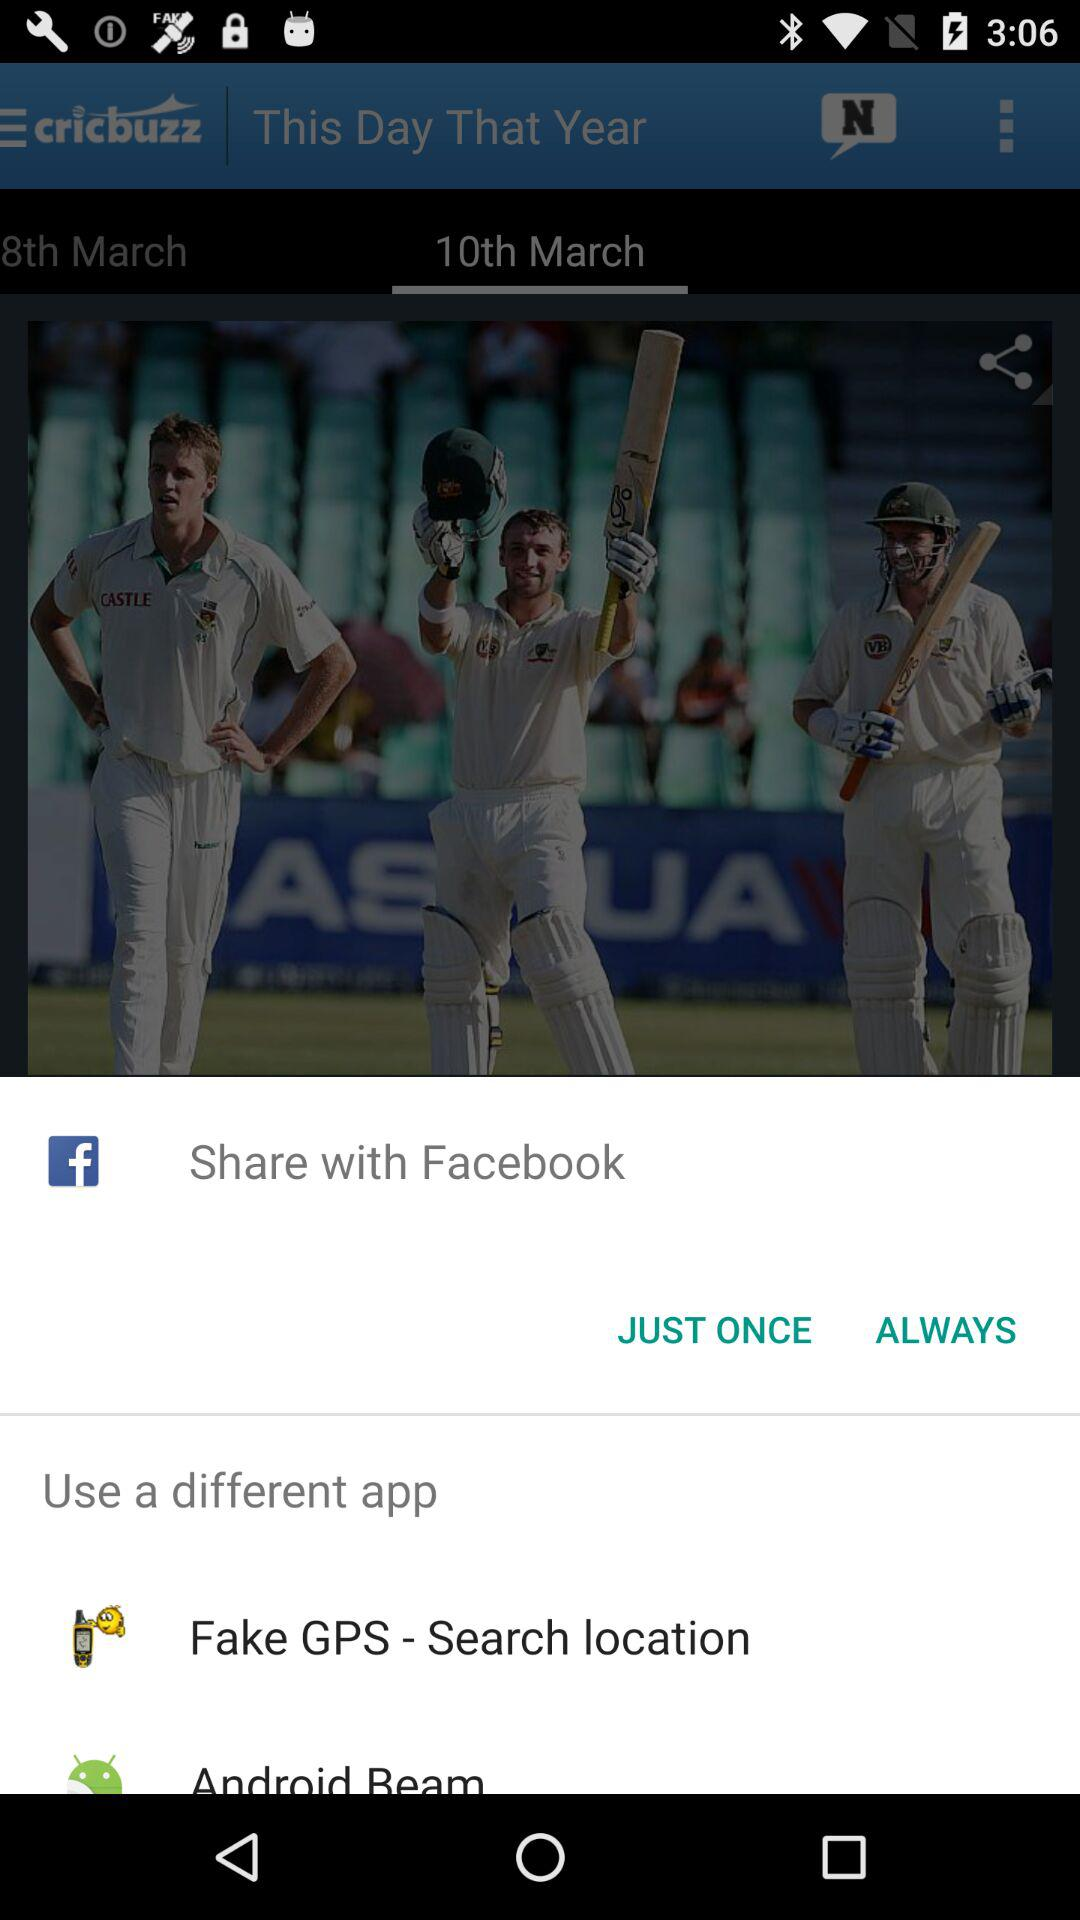What are the different application options that can be used? The different application options are "Fake GPS - Search location" and "Android Beam". 